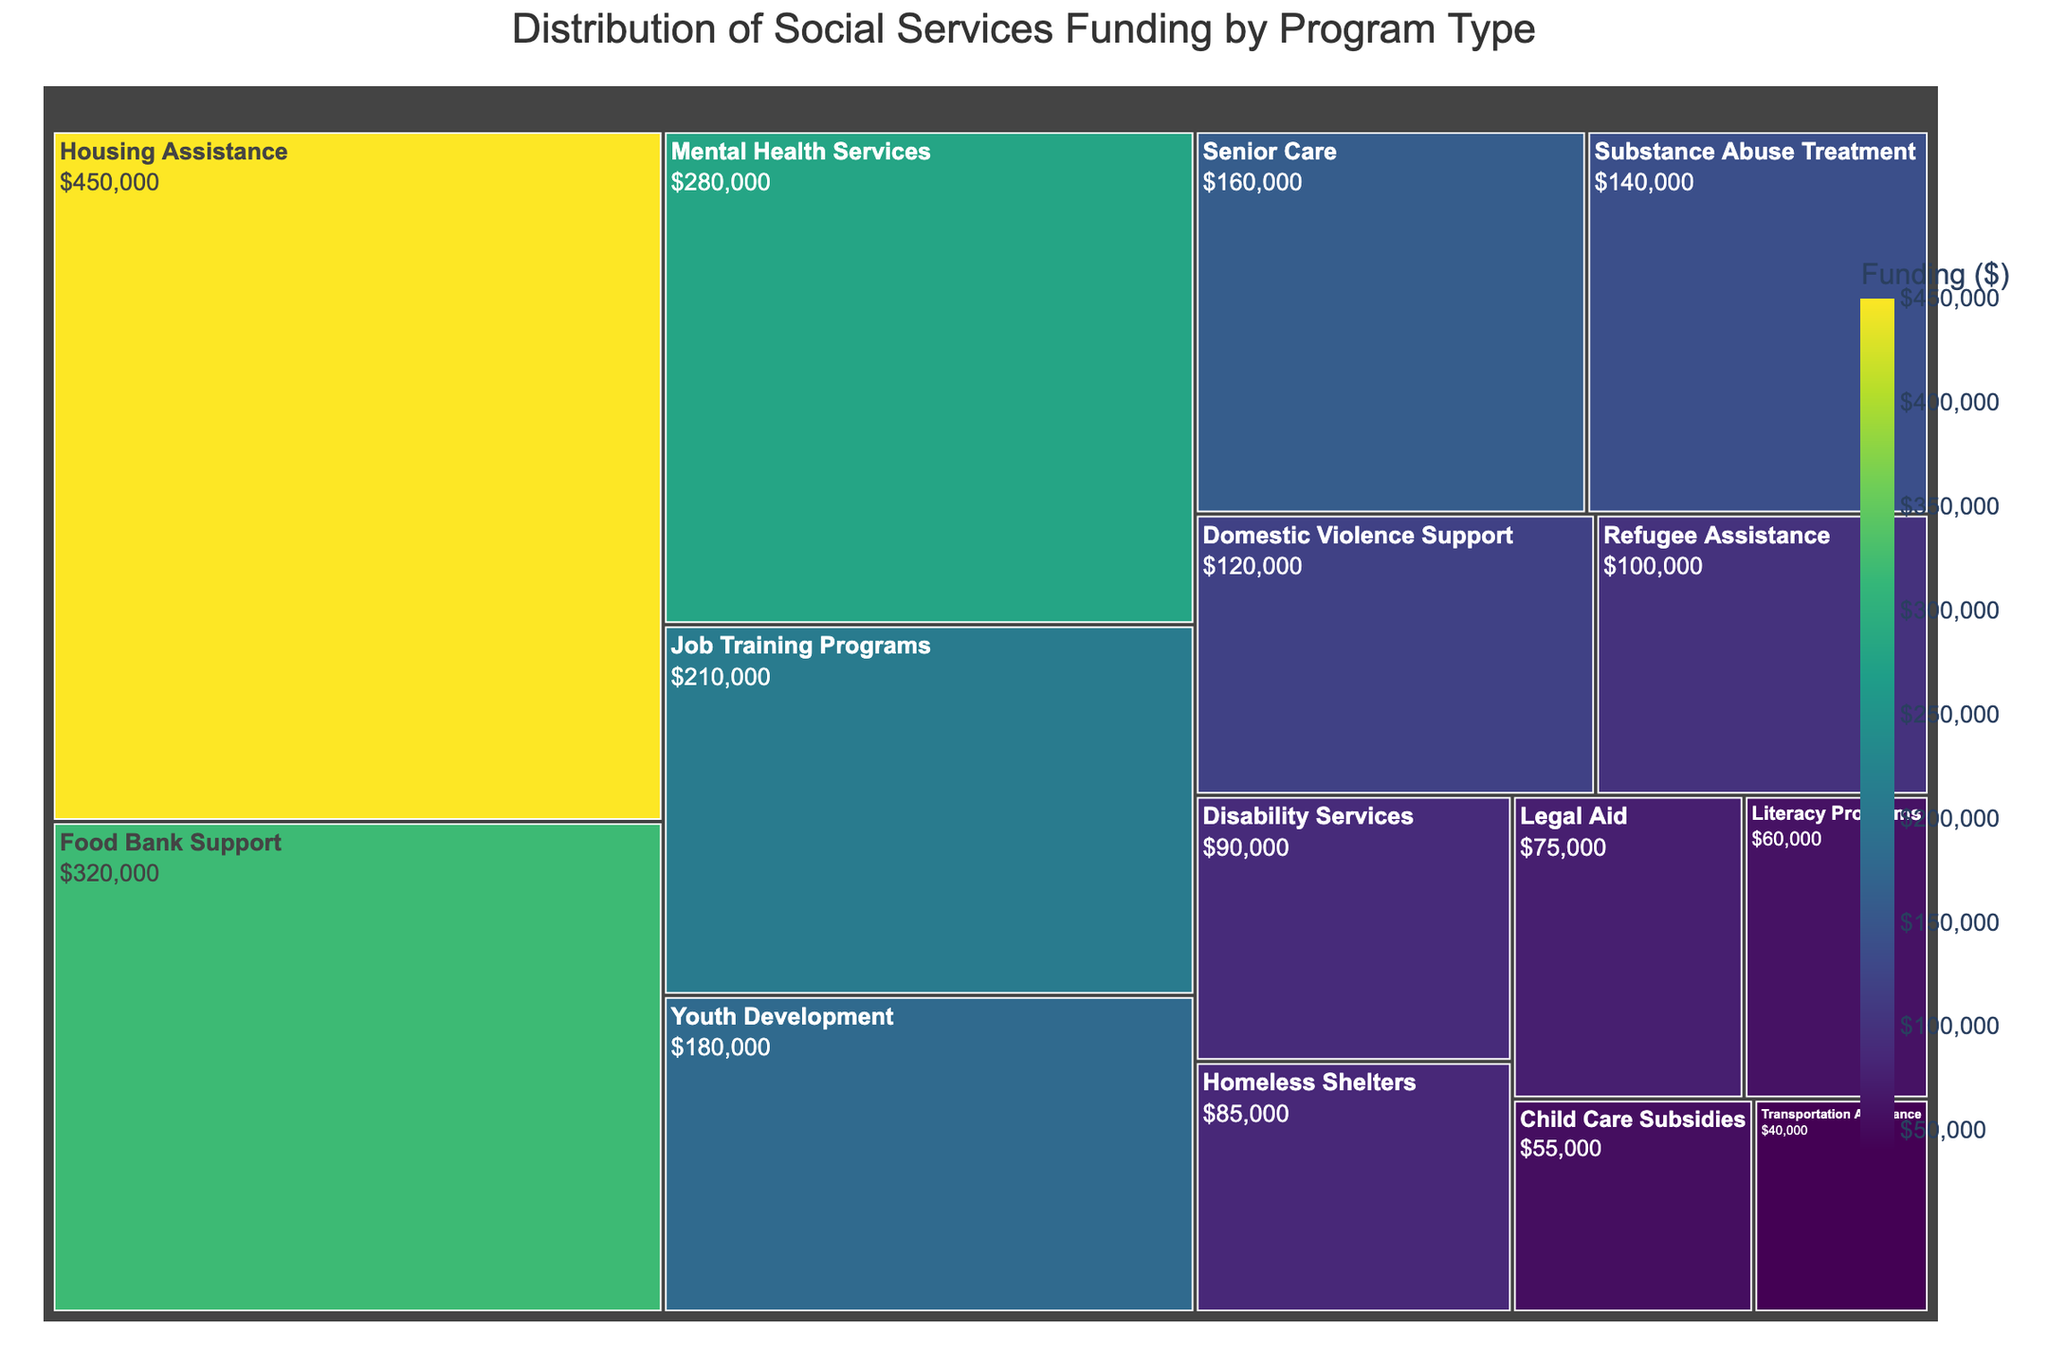What's the total funding for Housing Assistance and Food Bank Support? Housing Assistance has $450,000 and Food Bank Support has $320,000. Summing them up: $450,000 + $320,000 = $770,000
Answer: $770,000 Which program received the most funding? By looking at the size of the treemap tiles and the dollar values, Housing Assistance has the most funding at $450,000
Answer: Housing Assistance What is the funding difference between Mental Health Services and Job Training Programs? Mental Health Services received $280,000 and Job Training Programs got $210,000. The difference is $280,000 - $210,000 = $70,000
Answer: $70,000 How much more funding did Senior Care receive compared to Disability Services? Senior Care received $160,000 and Disability Services received $90,000. The difference is $160,000 - $90,000 = $70,000
Answer: $70,000 Which program has roughly half the funding of Youth Development? Youth Development has $180,000. Half of that is $180,000 / 2 = $90,000. Disability Services received $90,000, which is half of Youth Development's funding
Answer: Disability Services What is the combined funding for the two least funded programs? The two least funded programs are Child Care Subsidies ($55,000) and Transportation Assistance ($40,000). Combined, their funding is $55,000 + $40,000 = $95,000
Answer: $95,000 Which program received more funding: Legal Aid or Homeless Shelters? By comparing the funding amounts, Legal Aid received $75,000 while Homeless Shelters received $85,000. Homeless Shelters received more funding
Answer: Homeless Shelters What is the average funding for the top three funded programs? The top three programs are Housing Assistance ($450,000), Food Bank Support ($320,000), and Mental Health Services ($280,000). The average is calculated by summing these amounts and dividing by 3: ($450,000 + $320,000 + $280,000) / 3 = $1,050,000 / 3 = $350,000
Answer: $350,000 How many programs received funding greater than $200,000? The programs that received greater than $200,000 are Housing Assistance ($450,000), Food Bank Support ($320,000), Mental Health Services ($280,000), and Job Training Programs ($210,000). There are 4 such programs
Answer: 4 Which program received the closest amount of funding to $100,000? Refugee Assistance received $100,000, which exactly matches the given amount
Answer: Refugee Assistance 